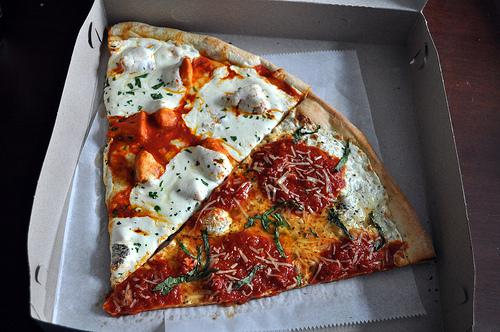Question: what is in the box?
Choices:
A. Cake.
B. Pie.
C. Pizza.
D. Bread.
Answer with the letter. Answer: C Question: when was the picture taken?
Choices:
A. At night.
B. At dawn.
C. During the day.
D. At dusk.
Answer with the letter. Answer: C Question: why is the pizza there?
Choices:
A. So it can be baked.
B. So it can be sold.
C. So it can be bought.
D. So someone can eat it.
Answer with the letter. Answer: D Question: what is on the pizza?
Choices:
A. Pepperoni.
B. Cheese and sauce.
C. Sausage.
D. Bacon.
Answer with the letter. Answer: B Question: how many slices are in the box?
Choices:
A. Two.
B. Four.
C. Five.
D. None.
Answer with the letter. Answer: A 